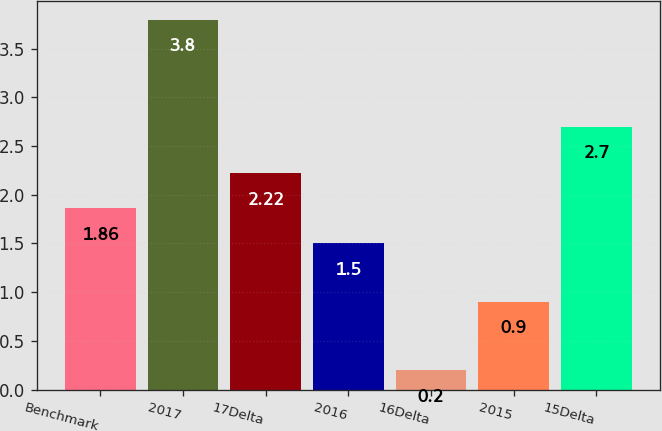Convert chart to OTSL. <chart><loc_0><loc_0><loc_500><loc_500><bar_chart><fcel>Benchmark<fcel>2017<fcel>17Delta<fcel>2016<fcel>16Delta<fcel>2015<fcel>15Delta<nl><fcel>1.86<fcel>3.8<fcel>2.22<fcel>1.5<fcel>0.2<fcel>0.9<fcel>2.7<nl></chart> 